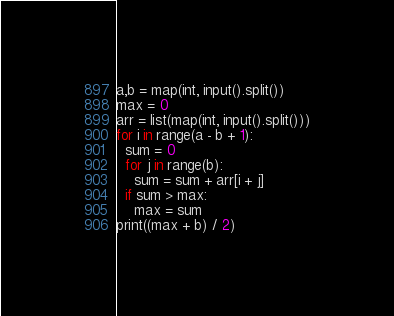<code> <loc_0><loc_0><loc_500><loc_500><_Python_>a,b = map(int, input().split())
max = 0
arr = list(map(int, input().split()))
for i in range(a - b + 1):
  sum = 0
  for j in range(b):
    sum = sum + arr[i + j]
  if sum > max:
    max = sum
print((max + b) / 2)</code> 